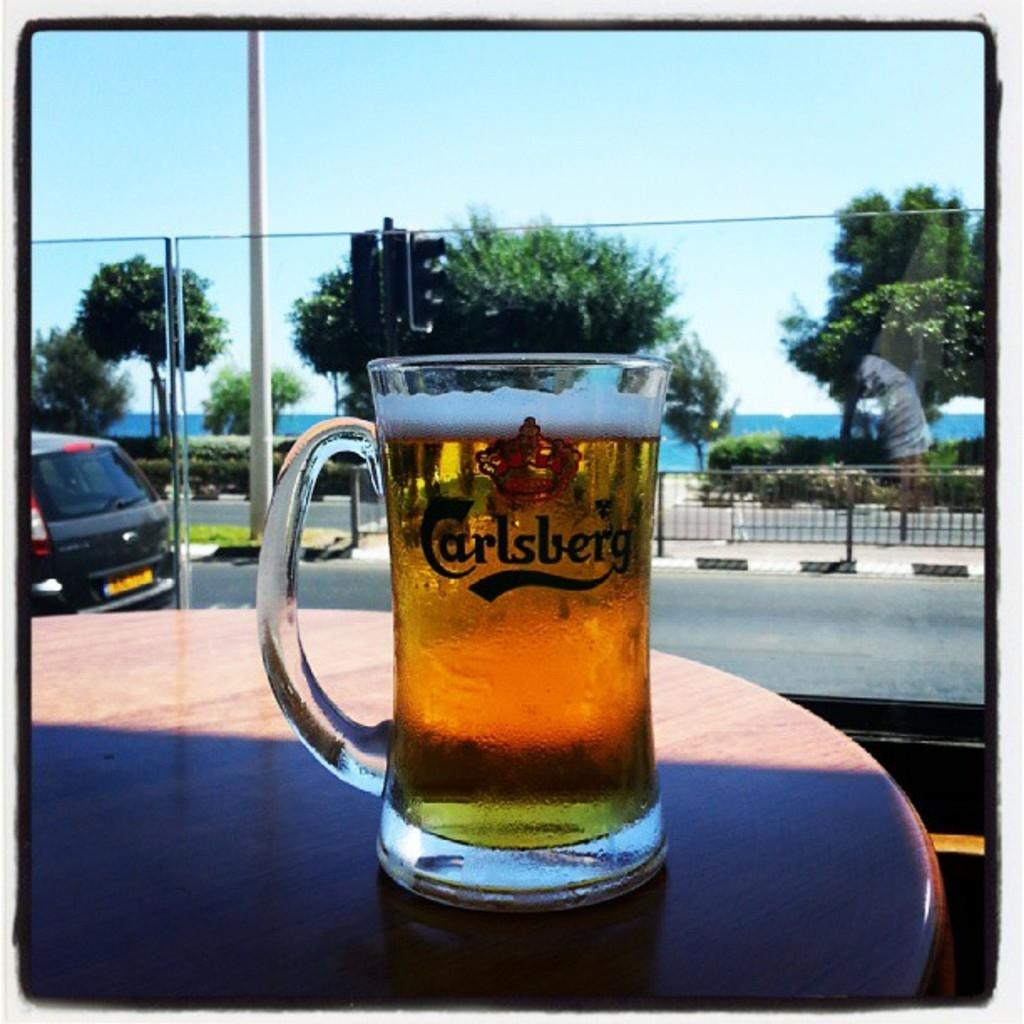What is in the glass that is visible in the image? There is a drink in the glass that is visible in the image. Where is the glass placed in the image? The glass is placed on a table in the image. What can be seen in the background of the image? There are trees, a traffic signal, and a car in the background of the image. How many ants are crawling on the glass in the image? There are no ants present in the image; the glass is filled with a drink and placed on a table. 